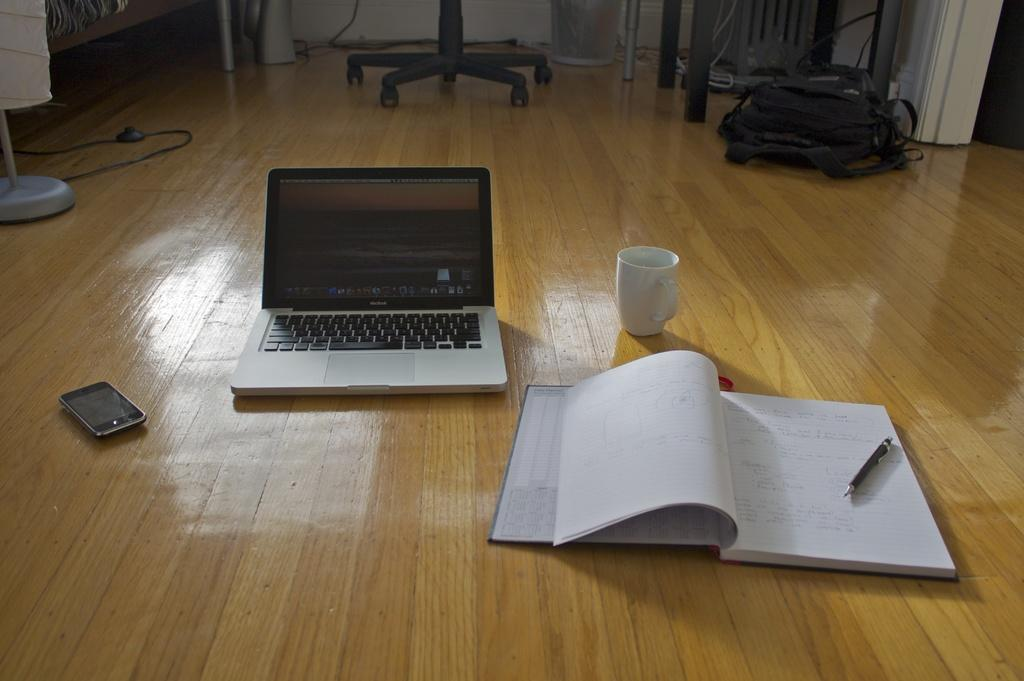What electronic device is visible in the image? There is a laptop in the image. What type of container is present in the image? There is a cup in the image. What stationery item can be seen on a book in the image? There is a pen on a book in the image. What communication device is visible in the image? There is a mobile in the image. What type of furniture is present in the image? There is a chair in the image. What type of bag is visible in the image? There is a bag in the image. What type of stand is present on the wooden floor in the image? There is a stand on the wooden floor in the image. What can be seen in the background of the image? In the background, there are cables and a white wall. What type of beast can be seen roaming around in the image? There is no beast present in the image. What is the main interest of the person in the image? The image does not provide enough information to determine the main interest of the person. 